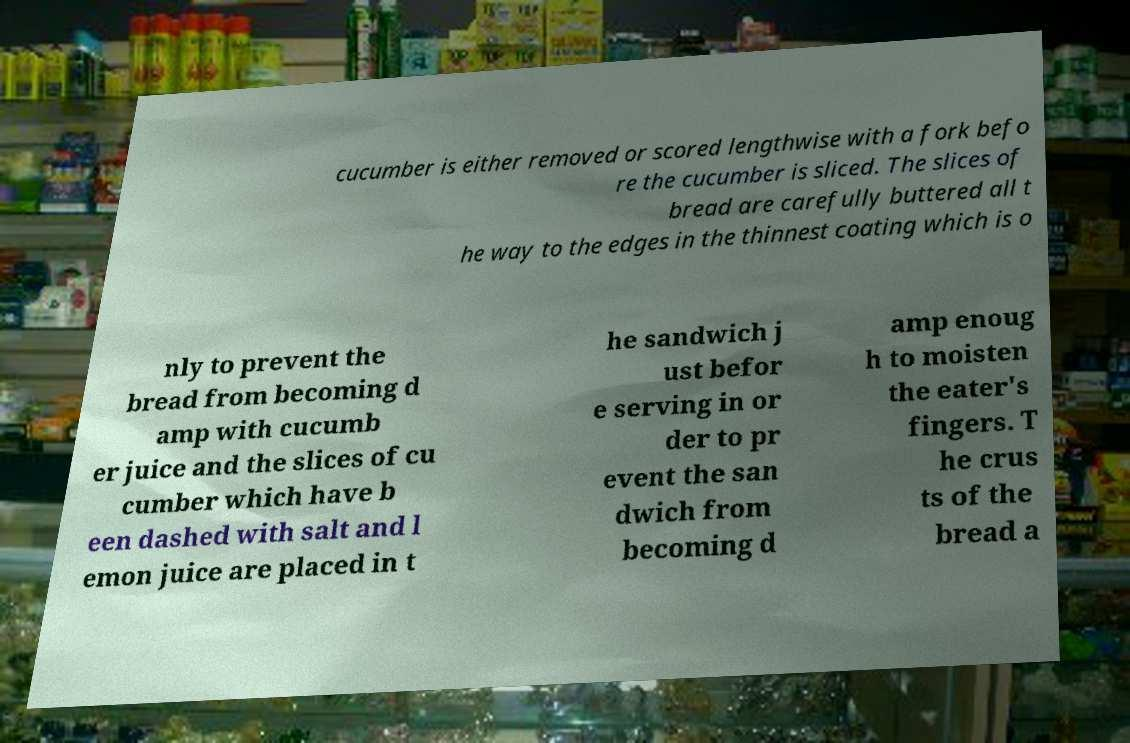Could you assist in decoding the text presented in this image and type it out clearly? cucumber is either removed or scored lengthwise with a fork befo re the cucumber is sliced. The slices of bread are carefully buttered all t he way to the edges in the thinnest coating which is o nly to prevent the bread from becoming d amp with cucumb er juice and the slices of cu cumber which have b een dashed with salt and l emon juice are placed in t he sandwich j ust befor e serving in or der to pr event the san dwich from becoming d amp enoug h to moisten the eater's fingers. T he crus ts of the bread a 